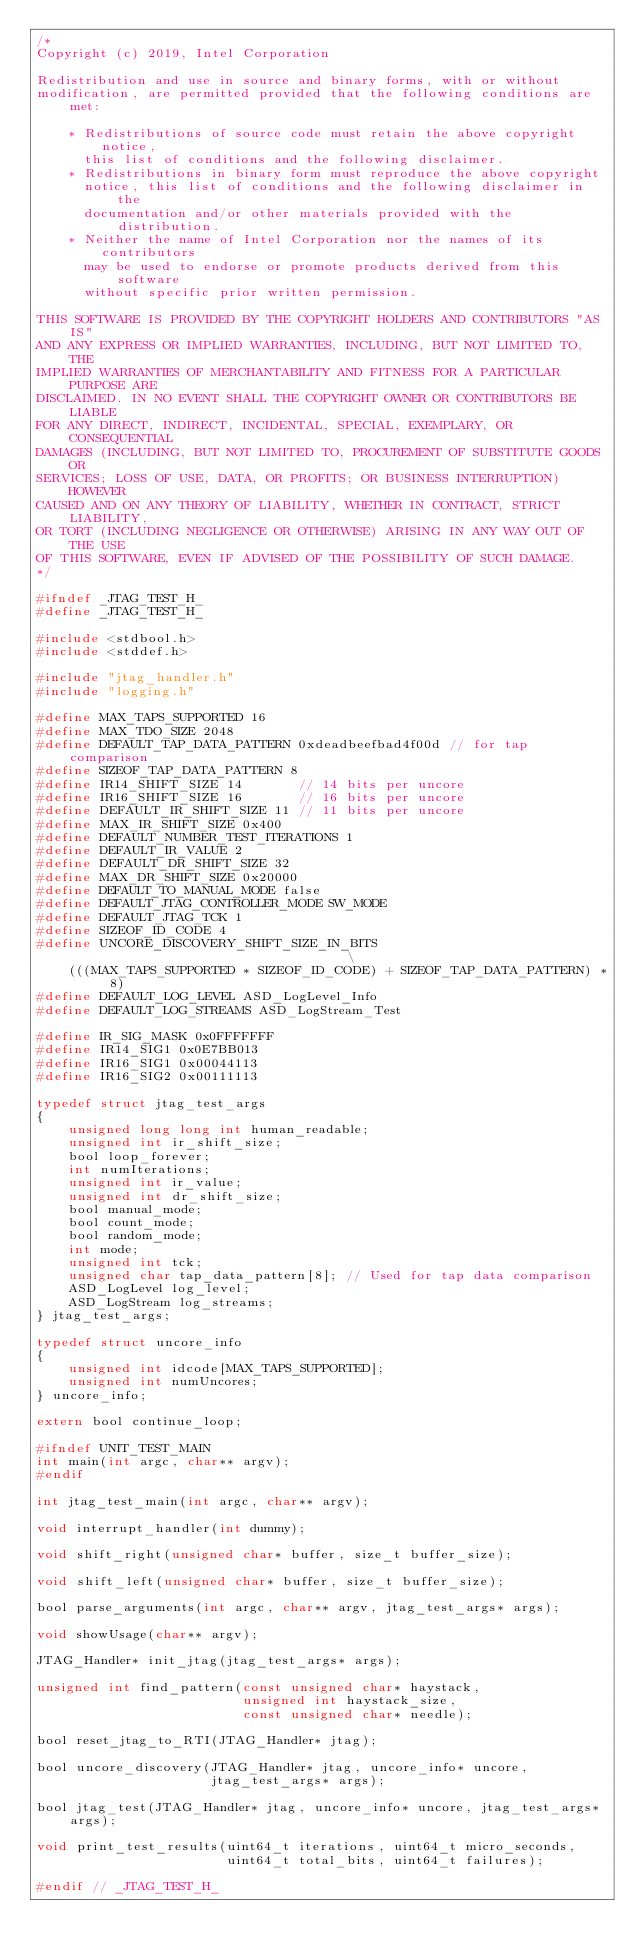Convert code to text. <code><loc_0><loc_0><loc_500><loc_500><_C_>/*
Copyright (c) 2019, Intel Corporation

Redistribution and use in source and binary forms, with or without
modification, are permitted provided that the following conditions are met:

    * Redistributions of source code must retain the above copyright notice,
      this list of conditions and the following disclaimer.
    * Redistributions in binary form must reproduce the above copyright
      notice, this list of conditions and the following disclaimer in the
      documentation and/or other materials provided with the distribution.
    * Neither the name of Intel Corporation nor the names of its contributors
      may be used to endorse or promote products derived from this software
      without specific prior written permission.

THIS SOFTWARE IS PROVIDED BY THE COPYRIGHT HOLDERS AND CONTRIBUTORS "AS IS"
AND ANY EXPRESS OR IMPLIED WARRANTIES, INCLUDING, BUT NOT LIMITED TO, THE
IMPLIED WARRANTIES OF MERCHANTABILITY AND FITNESS FOR A PARTICULAR PURPOSE ARE
DISCLAIMED. IN NO EVENT SHALL THE COPYRIGHT OWNER OR CONTRIBUTORS BE LIABLE
FOR ANY DIRECT, INDIRECT, INCIDENTAL, SPECIAL, EXEMPLARY, OR CONSEQUENTIAL
DAMAGES (INCLUDING, BUT NOT LIMITED TO, PROCUREMENT OF SUBSTITUTE GOODS OR
SERVICES; LOSS OF USE, DATA, OR PROFITS; OR BUSINESS INTERRUPTION) HOWEVER
CAUSED AND ON ANY THEORY OF LIABILITY, WHETHER IN CONTRACT, STRICT LIABILITY,
OR TORT (INCLUDING NEGLIGENCE OR OTHERWISE) ARISING IN ANY WAY OUT OF THE USE
OF THIS SOFTWARE, EVEN IF ADVISED OF THE POSSIBILITY OF SUCH DAMAGE.
*/

#ifndef _JTAG_TEST_H_
#define _JTAG_TEST_H_

#include <stdbool.h>
#include <stddef.h>

#include "jtag_handler.h"
#include "logging.h"

#define MAX_TAPS_SUPPORTED 16
#define MAX_TDO_SIZE 2048
#define DEFAULT_TAP_DATA_PATTERN 0xdeadbeefbad4f00d // for tap comparison
#define SIZEOF_TAP_DATA_PATTERN 8
#define IR14_SHIFT_SIZE 14       // 14 bits per uncore
#define IR16_SHIFT_SIZE 16       // 16 bits per uncore
#define DEFAULT_IR_SHIFT_SIZE 11 // 11 bits per uncore
#define MAX_IR_SHIFT_SIZE 0x400
#define DEFAULT_NUMBER_TEST_ITERATIONS 1
#define DEFAULT_IR_VALUE 2
#define DEFAULT_DR_SHIFT_SIZE 32
#define MAX_DR_SHIFT_SIZE 0x20000
#define DEFAULT_TO_MANUAL_MODE false
#define DEFAULT_JTAG_CONTROLLER_MODE SW_MODE
#define DEFAULT_JTAG_TCK 1
#define SIZEOF_ID_CODE 4
#define UNCORE_DISCOVERY_SHIFT_SIZE_IN_BITS                                    \
    (((MAX_TAPS_SUPPORTED * SIZEOF_ID_CODE) + SIZEOF_TAP_DATA_PATTERN) * 8)
#define DEFAULT_LOG_LEVEL ASD_LogLevel_Info
#define DEFAULT_LOG_STREAMS ASD_LogStream_Test

#define IR_SIG_MASK 0x0FFFFFFF
#define IR14_SIG1 0x0E7BB013
#define IR16_SIG1 0x00044113
#define IR16_SIG2 0x00111113

typedef struct jtag_test_args
{
    unsigned long long int human_readable;
    unsigned int ir_shift_size;
    bool loop_forever;
    int numIterations;
    unsigned int ir_value;
    unsigned int dr_shift_size;
    bool manual_mode;
    bool count_mode;
    bool random_mode;
    int mode;
    unsigned int tck;
    unsigned char tap_data_pattern[8]; // Used for tap data comparison
    ASD_LogLevel log_level;
    ASD_LogStream log_streams;
} jtag_test_args;

typedef struct uncore_info
{
    unsigned int idcode[MAX_TAPS_SUPPORTED];
    unsigned int numUncores;
} uncore_info;

extern bool continue_loop;

#ifndef UNIT_TEST_MAIN
int main(int argc, char** argv);
#endif

int jtag_test_main(int argc, char** argv);

void interrupt_handler(int dummy);

void shift_right(unsigned char* buffer, size_t buffer_size);

void shift_left(unsigned char* buffer, size_t buffer_size);

bool parse_arguments(int argc, char** argv, jtag_test_args* args);

void showUsage(char** argv);

JTAG_Handler* init_jtag(jtag_test_args* args);

unsigned int find_pattern(const unsigned char* haystack,
                          unsigned int haystack_size,
                          const unsigned char* needle);

bool reset_jtag_to_RTI(JTAG_Handler* jtag);

bool uncore_discovery(JTAG_Handler* jtag, uncore_info* uncore,
                      jtag_test_args* args);

bool jtag_test(JTAG_Handler* jtag, uncore_info* uncore, jtag_test_args* args);

void print_test_results(uint64_t iterations, uint64_t micro_seconds,
                        uint64_t total_bits, uint64_t failures);

#endif // _JTAG_TEST_H_
</code> 